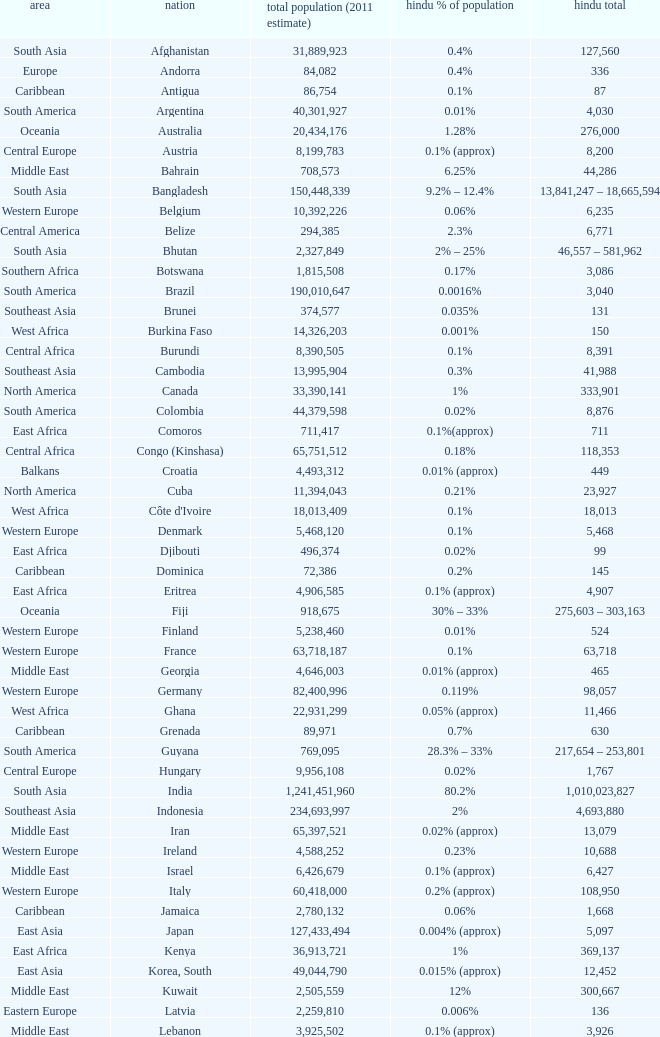Total Population (2011 est) larger than 30,262,610, and a Hindu total of 63,718 involves what country? France. 